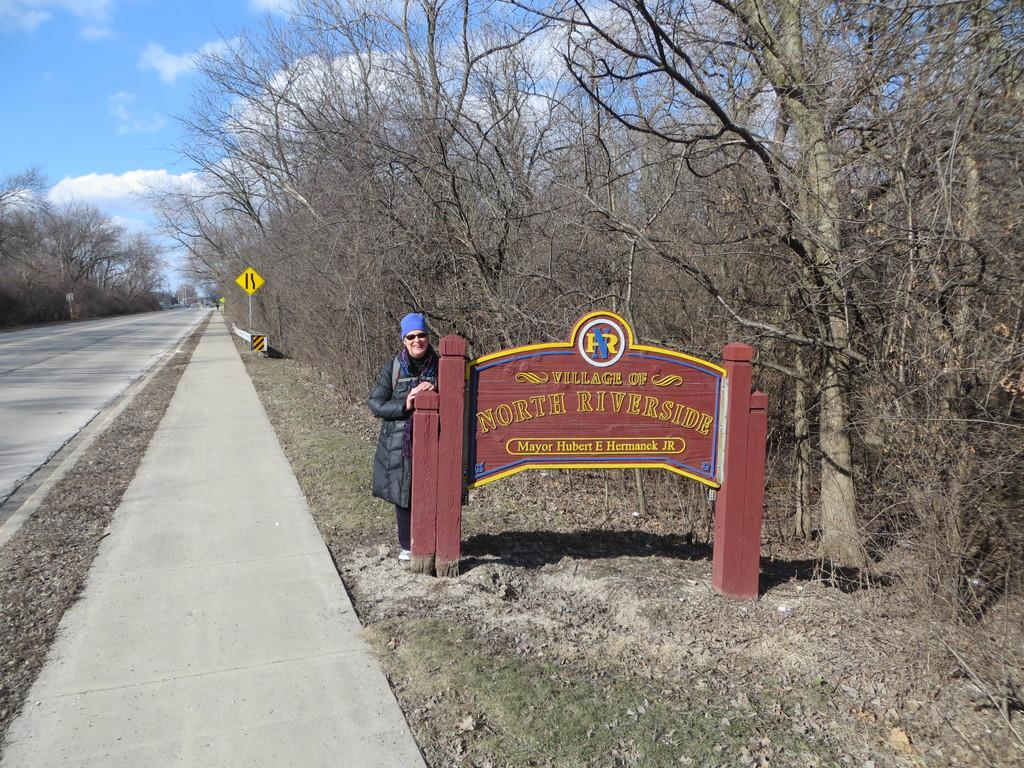<image>
Render a clear and concise summary of the photo. A person standing next to a sign for the village of North Riverside. 